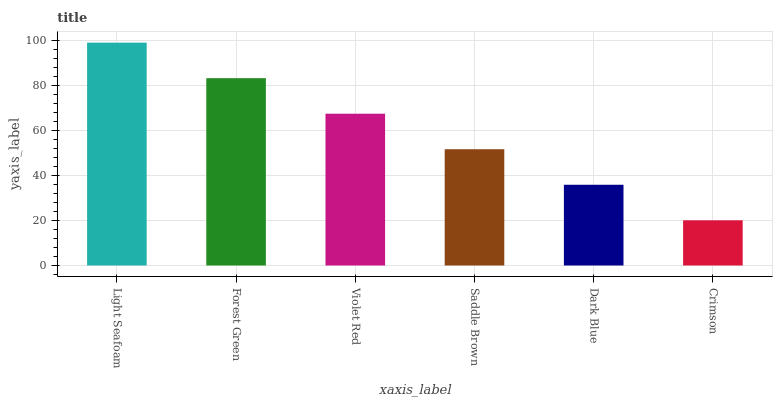Is Forest Green the minimum?
Answer yes or no. No. Is Forest Green the maximum?
Answer yes or no. No. Is Light Seafoam greater than Forest Green?
Answer yes or no. Yes. Is Forest Green less than Light Seafoam?
Answer yes or no. Yes. Is Forest Green greater than Light Seafoam?
Answer yes or no. No. Is Light Seafoam less than Forest Green?
Answer yes or no. No. Is Violet Red the high median?
Answer yes or no. Yes. Is Saddle Brown the low median?
Answer yes or no. Yes. Is Dark Blue the high median?
Answer yes or no. No. Is Dark Blue the low median?
Answer yes or no. No. 